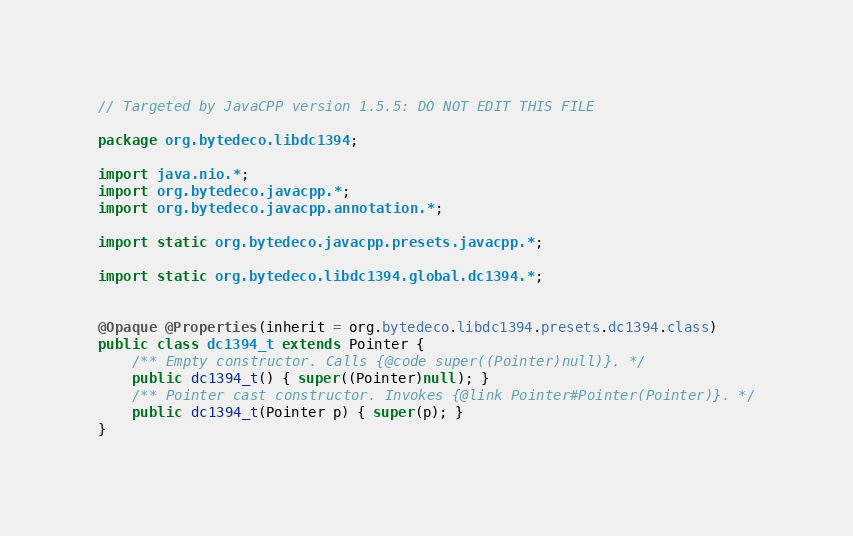Convert code to text. <code><loc_0><loc_0><loc_500><loc_500><_Java_>// Targeted by JavaCPP version 1.5.5: DO NOT EDIT THIS FILE

package org.bytedeco.libdc1394;

import java.nio.*;
import org.bytedeco.javacpp.*;
import org.bytedeco.javacpp.annotation.*;

import static org.bytedeco.javacpp.presets.javacpp.*;

import static org.bytedeco.libdc1394.global.dc1394.*;


@Opaque @Properties(inherit = org.bytedeco.libdc1394.presets.dc1394.class)
public class dc1394_t extends Pointer {
    /** Empty constructor. Calls {@code super((Pointer)null)}. */
    public dc1394_t() { super((Pointer)null); }
    /** Pointer cast constructor. Invokes {@link Pointer#Pointer(Pointer)}. */
    public dc1394_t(Pointer p) { super(p); }
}
</code> 